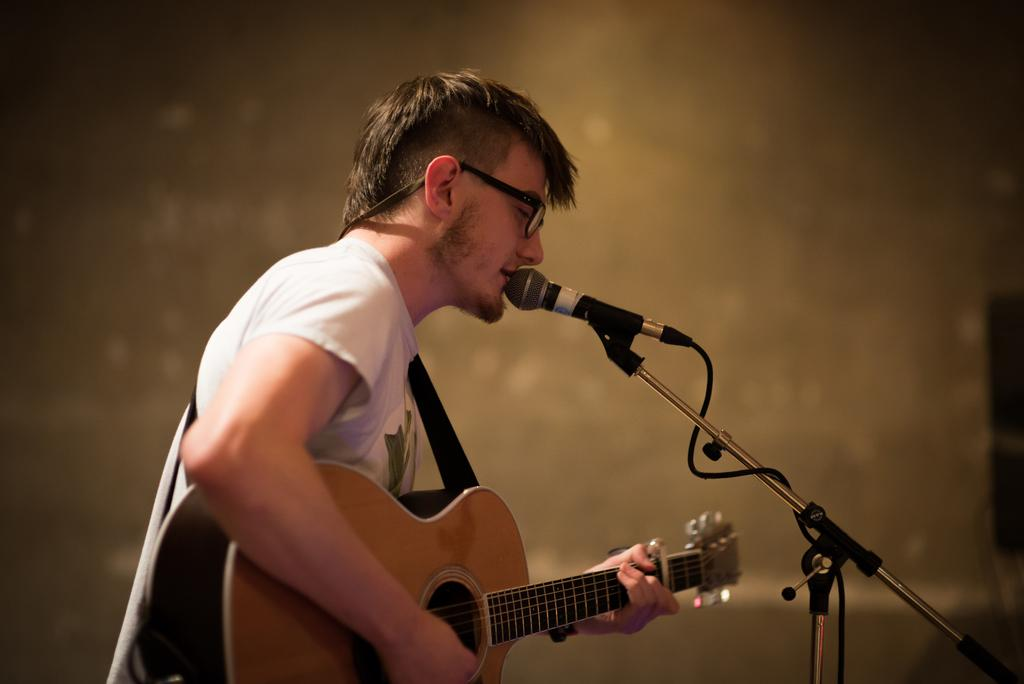What is the man in the image doing? The man is playing a guitar and singing. What object is the man holding while singing? The man is holding a microphone. What can be seen in the background of the image? There is a stand in the image. What accessory is the man wearing? The man is wearing spectacles. Can you tell me how many rings the man is wearing on his left hand in the image? There is no mention of rings in the image; the man is wearing spectacles. Is the man playing basketball in the image? No, the man is not playing basketball in the image; he is playing a guitar and singing. 